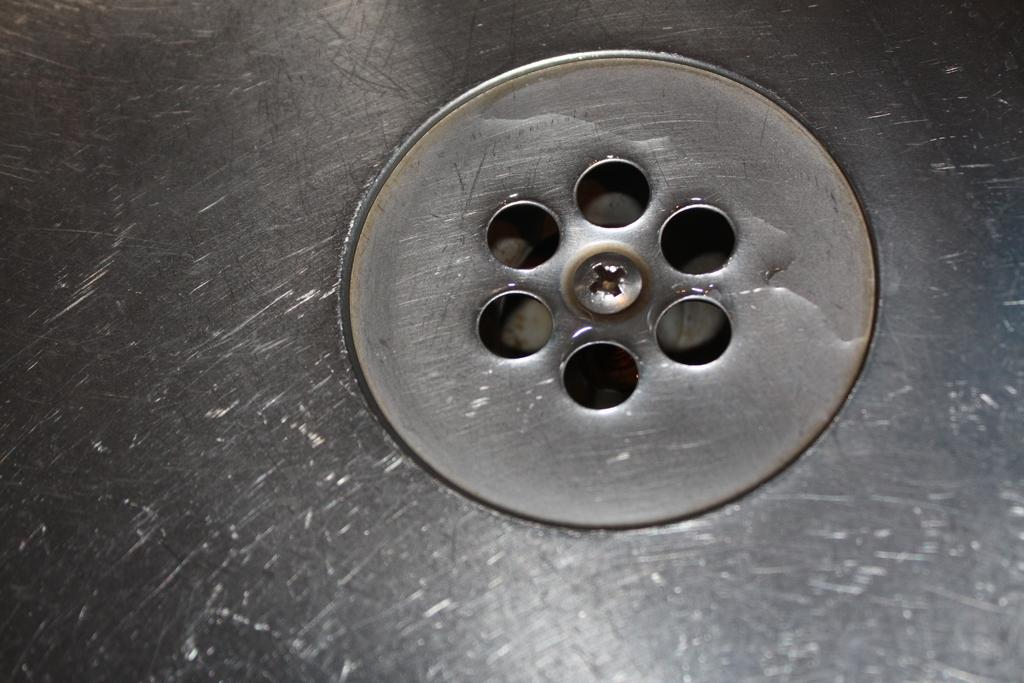What type of holes are visible in the image? There are drain holes in the image. Where are these drain holes located? The drain holes are part of a sink. What type of farm animals can be seen attacking the sink in the image? There are no farm animals or attacks depicted in the image; it only shows drain holes in a sink. 